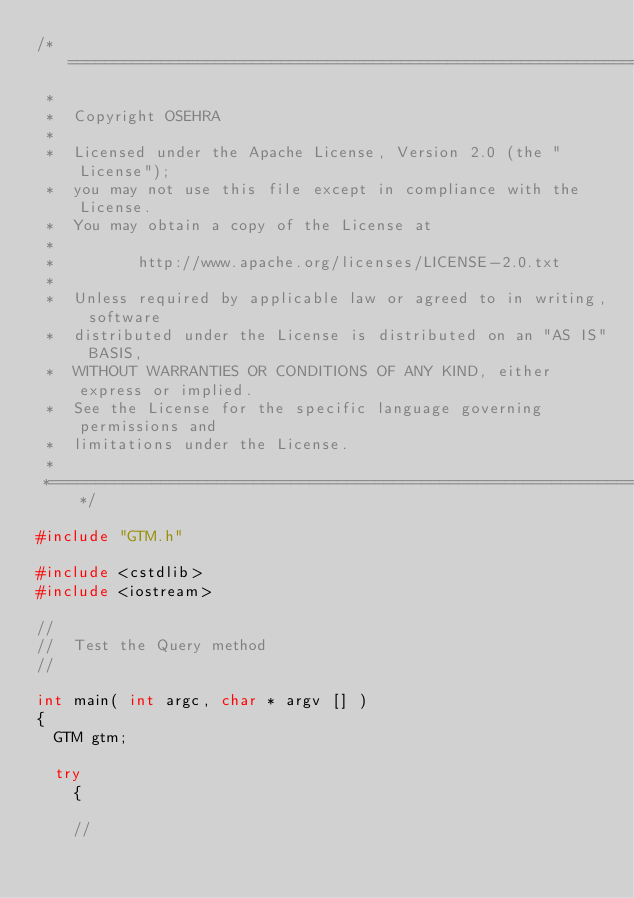Convert code to text. <code><loc_0><loc_0><loc_500><loc_500><_C++_>/*=========================================================================
 *
 *  Copyright OSEHRA
 *
 *  Licensed under the Apache License, Version 2.0 (the "License");
 *  you may not use this file except in compliance with the License.
 *  You may obtain a copy of the License at
 *
 *         http://www.apache.org/licenses/LICENSE-2.0.txt
 *
 *  Unless required by applicable law or agreed to in writing, software
 *  distributed under the License is distributed on an "AS IS" BASIS,
 *  WITHOUT WARRANTIES OR CONDITIONS OF ANY KIND, either express or implied.
 *  See the License for the specific language governing permissions and
 *  limitations under the License.
 *
 *=========================================================================*/

#include "GTM.h"

#include <cstdlib>
#include <iostream>

//
//  Test the Query method
//

int main( int argc, char * argv [] )
{
  GTM gtm;

  try
    {

    //</code> 